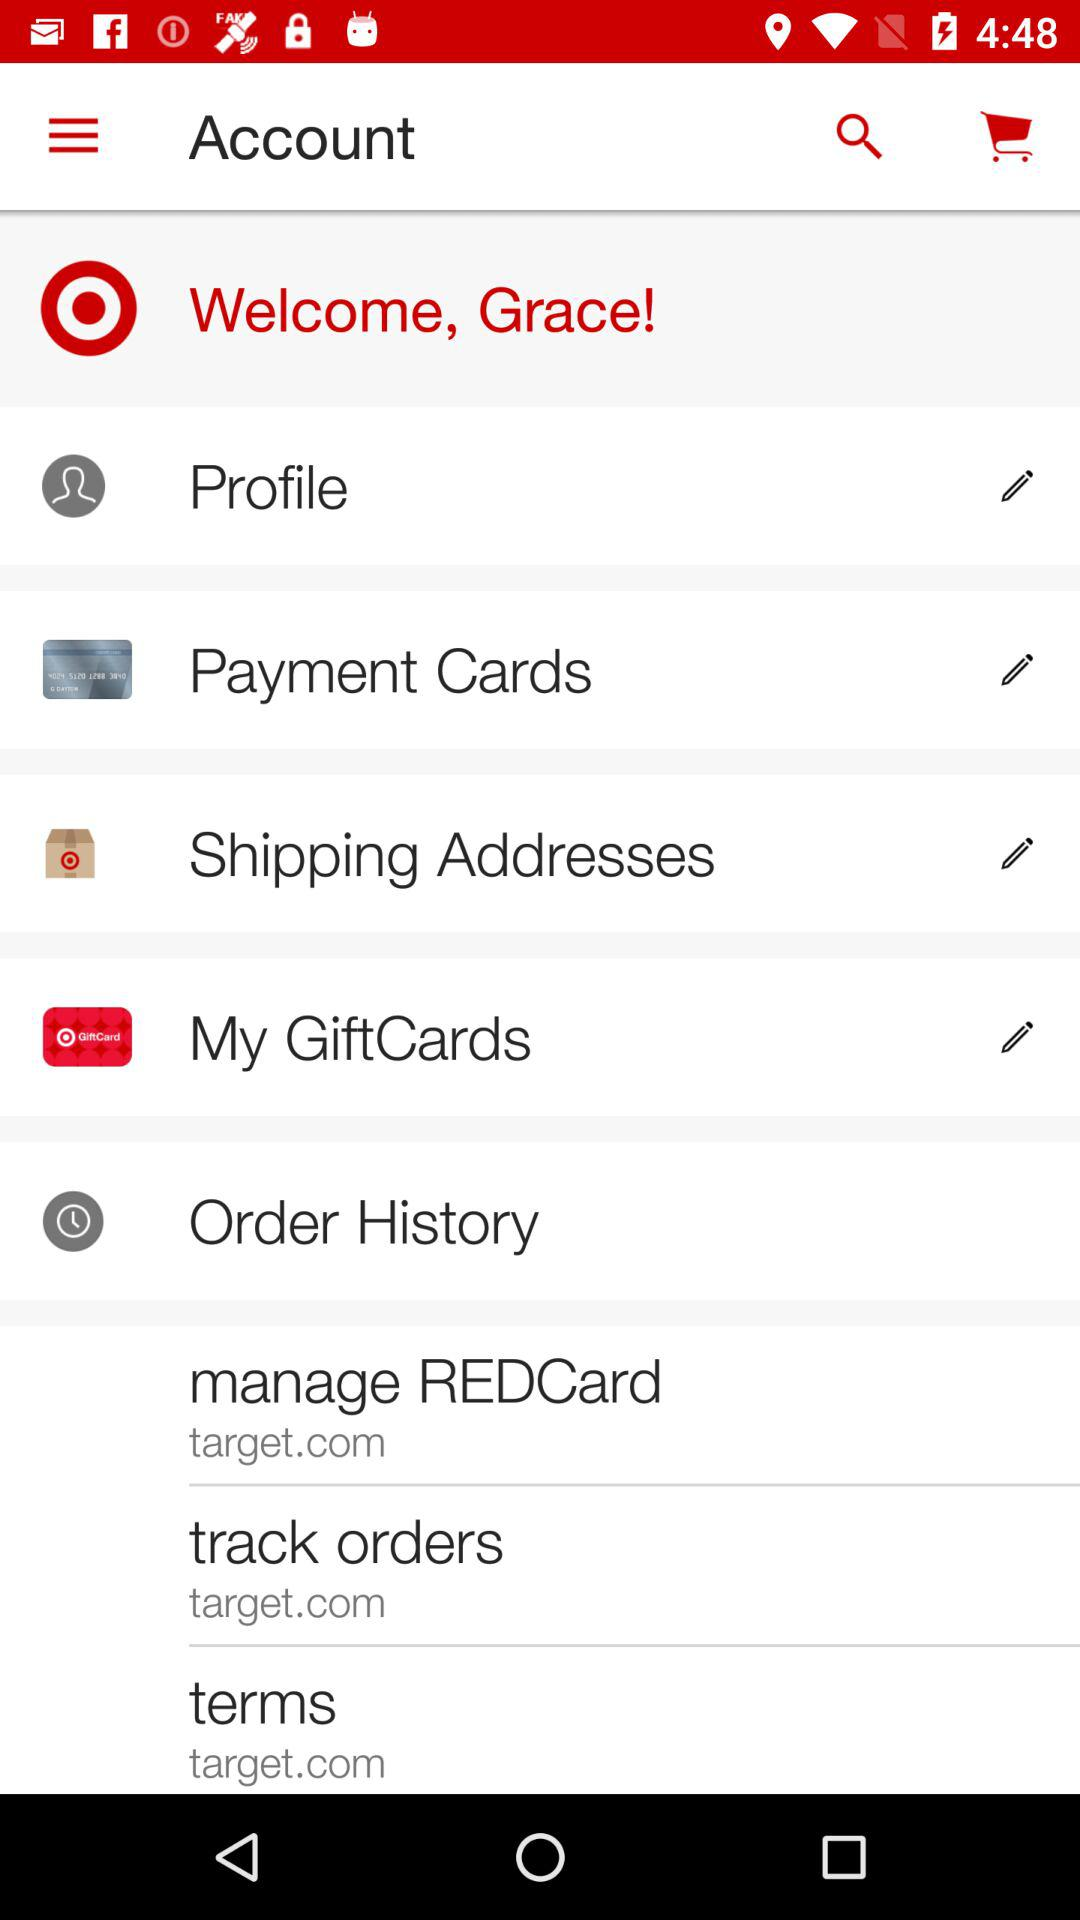What website can we use to track orders? The website we can use is "target.com". 